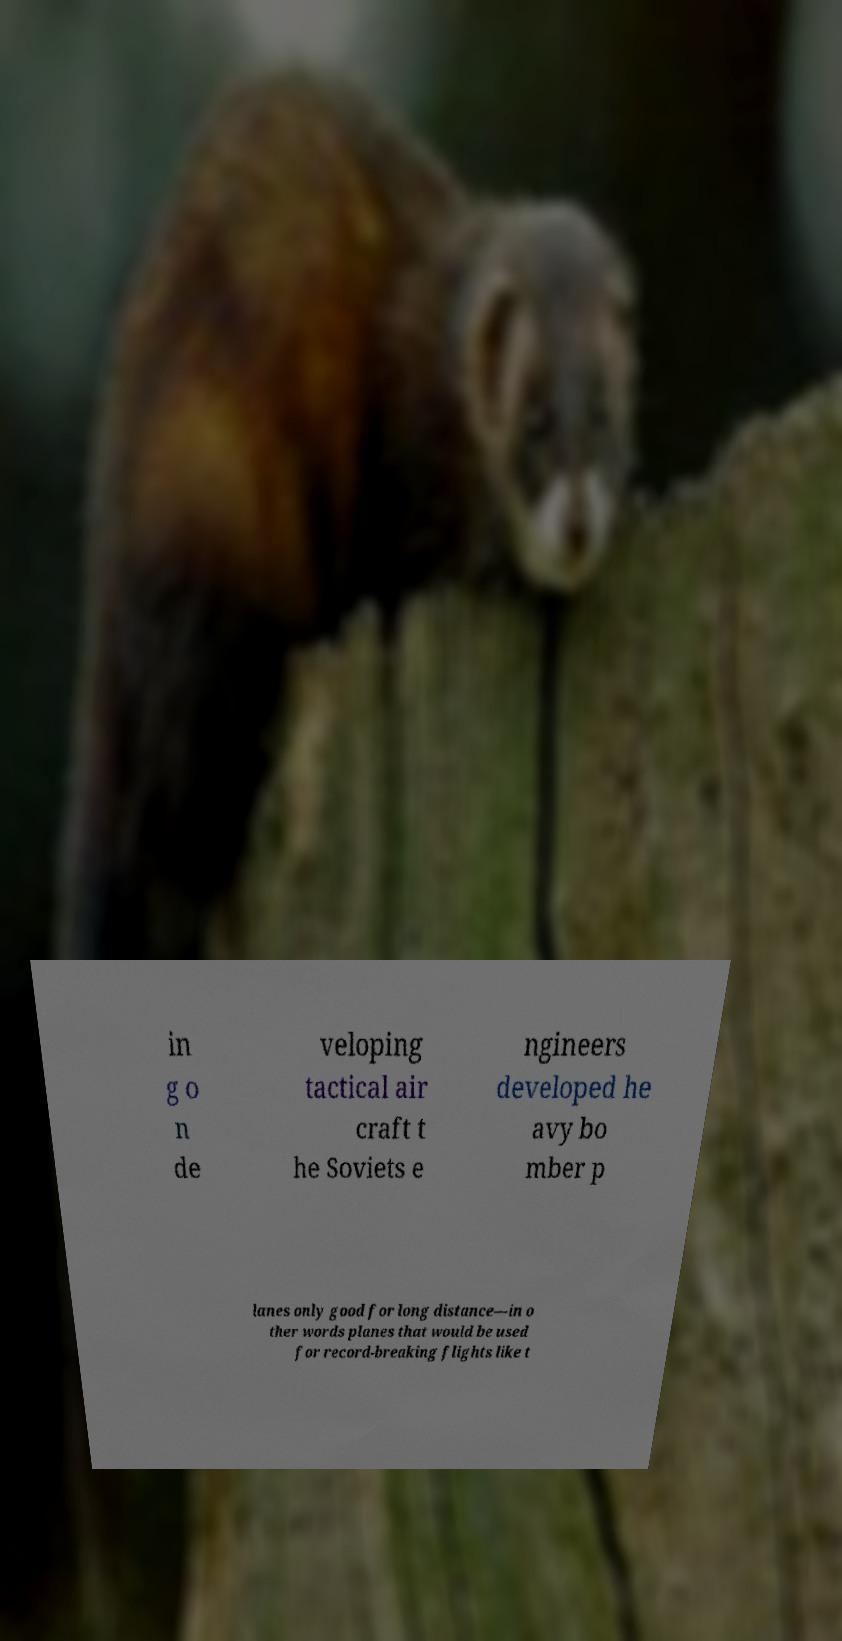For documentation purposes, I need the text within this image transcribed. Could you provide that? in g o n de veloping tactical air craft t he Soviets e ngineers developed he avy bo mber p lanes only good for long distance—in o ther words planes that would be used for record-breaking flights like t 